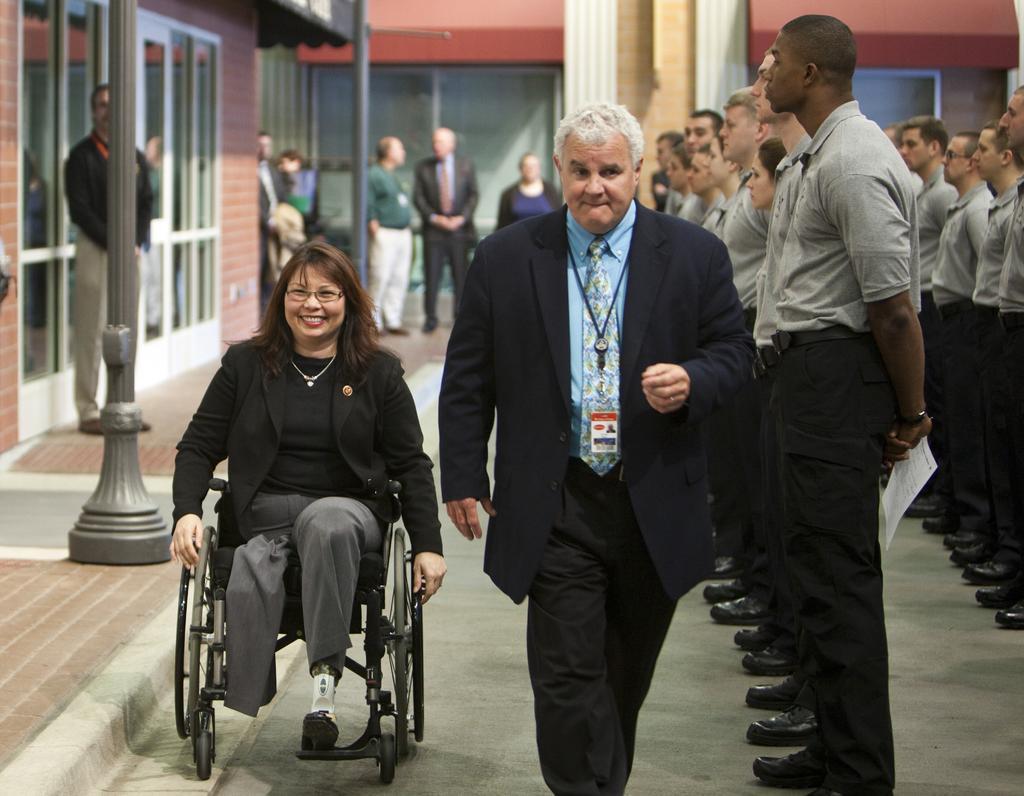Can you describe this image briefly? On the left side of this image I can see a woman is sitting on the wheelchair and smiling. Beside her a man is wearing a black color suit, blue color shirt and walking on the floor. On the right side, I can see few people are wearing t-shirts, black color trousers and standing facing towards the left side. On the left side, I can see a building along with the pillars and a person is standing on the floor. In the background, I can see some more people are standing and also there is a wall. 